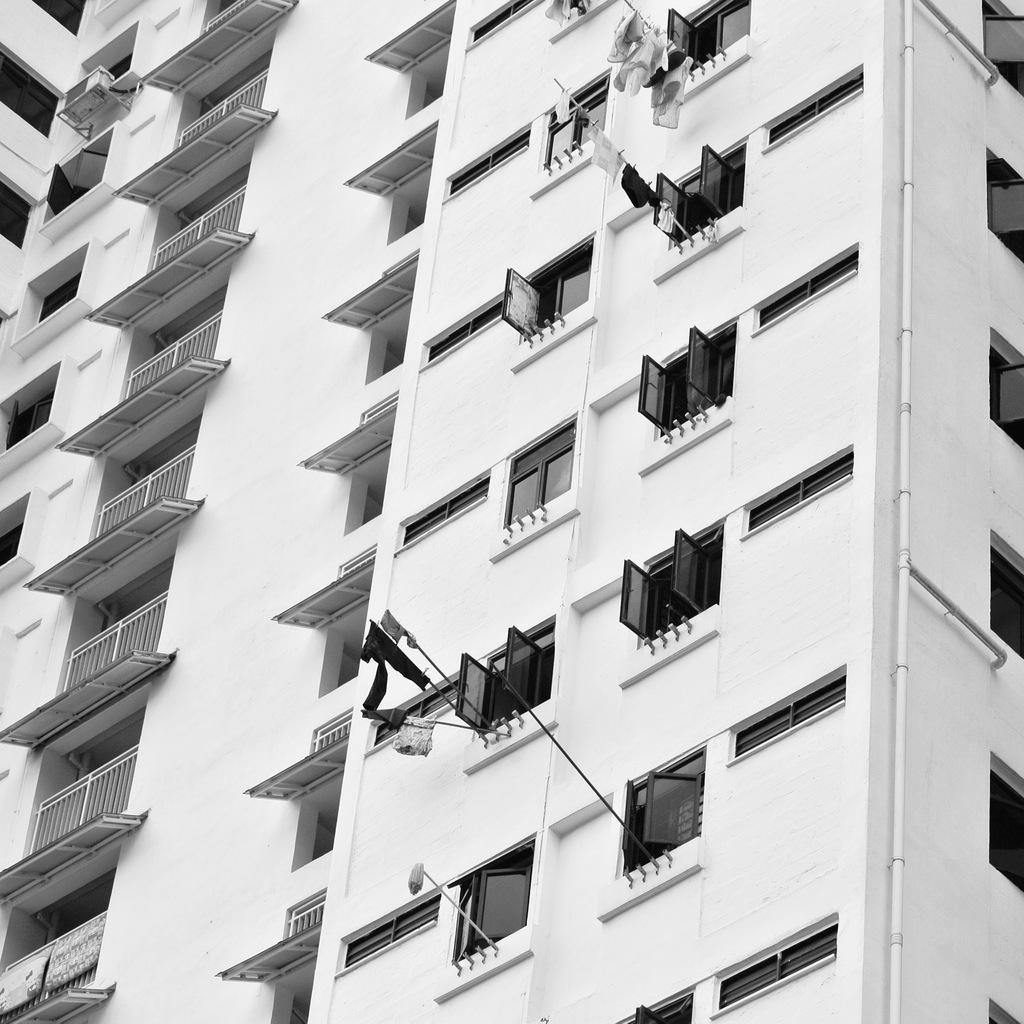In one or two sentences, can you explain what this image depicts? In this picture there is a building and there are few glass windows opened and there are few clothes attached to a pole. 